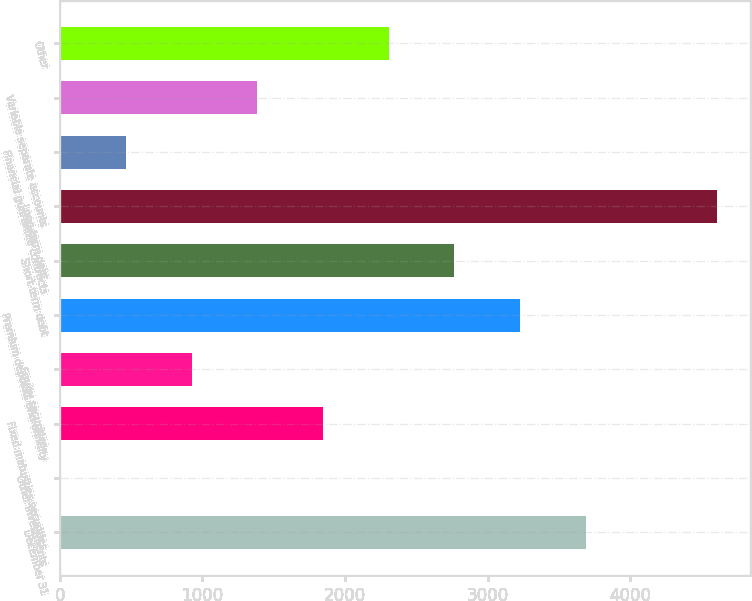Convert chart to OTSL. <chart><loc_0><loc_0><loc_500><loc_500><bar_chart><fcel>December 31<fcel>Other investments<fcel>Fixed maturities securities<fcel>Equity securities<fcel>Premium deposits and annuity<fcel>Short-term debt<fcel>Long-term debt<fcel>Financial guarantee contracts<fcel>Variable separate accounts<fcel>Other<nl><fcel>3687.48<fcel>3<fcel>1845.24<fcel>924.12<fcel>3226.92<fcel>2766.36<fcel>4608.6<fcel>463.56<fcel>1384.68<fcel>2305.8<nl></chart> 